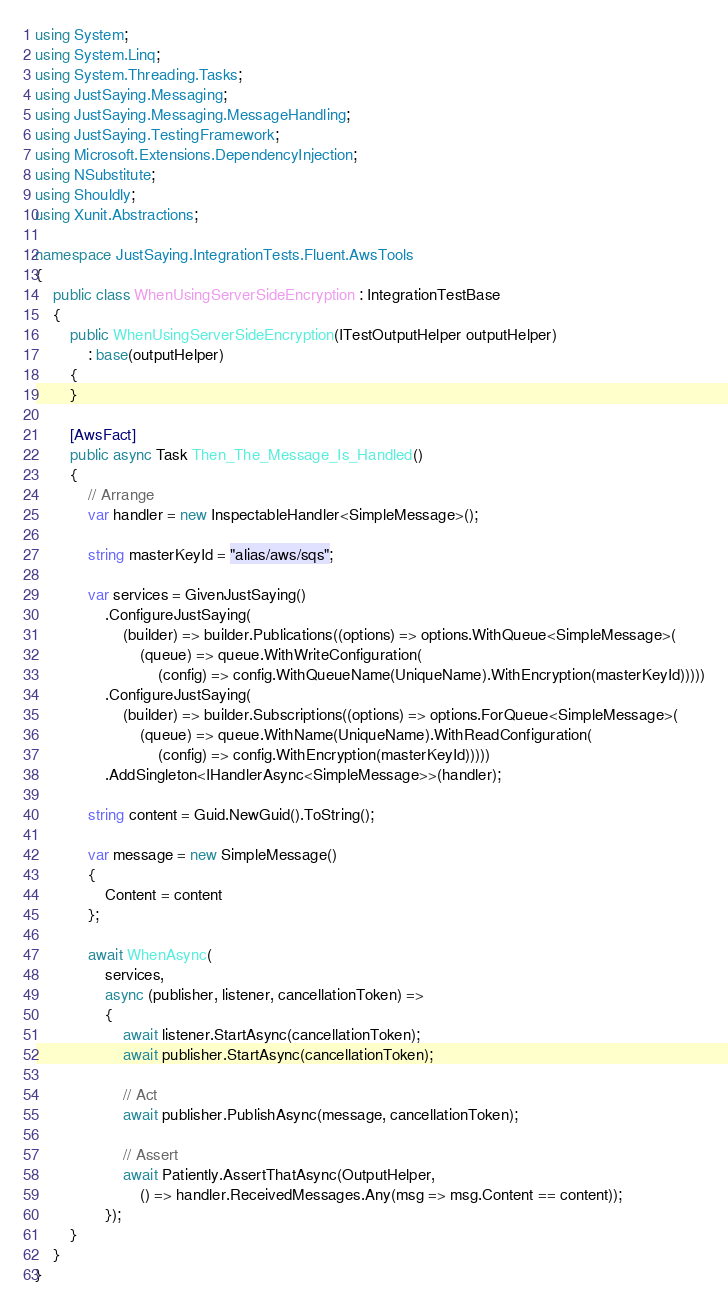<code> <loc_0><loc_0><loc_500><loc_500><_C#_>using System;
using System.Linq;
using System.Threading.Tasks;
using JustSaying.Messaging;
using JustSaying.Messaging.MessageHandling;
using JustSaying.TestingFramework;
using Microsoft.Extensions.DependencyInjection;
using NSubstitute;
using Shouldly;
using Xunit.Abstractions;

namespace JustSaying.IntegrationTests.Fluent.AwsTools
{
    public class WhenUsingServerSideEncryption : IntegrationTestBase
    {
        public WhenUsingServerSideEncryption(ITestOutputHelper outputHelper)
            : base(outputHelper)
        {
        }

        [AwsFact]
        public async Task Then_The_Message_Is_Handled()
        {
            // Arrange
            var handler = new InspectableHandler<SimpleMessage>();

            string masterKeyId = "alias/aws/sqs";

            var services = GivenJustSaying()
                .ConfigureJustSaying(
                    (builder) => builder.Publications((options) => options.WithQueue<SimpleMessage>(
                        (queue) => queue.WithWriteConfiguration(
                            (config) => config.WithQueueName(UniqueName).WithEncryption(masterKeyId)))))
                .ConfigureJustSaying(
                    (builder) => builder.Subscriptions((options) => options.ForQueue<SimpleMessage>(
                        (queue) => queue.WithName(UniqueName).WithReadConfiguration(
                            (config) => config.WithEncryption(masterKeyId)))))
                .AddSingleton<IHandlerAsync<SimpleMessage>>(handler);

            string content = Guid.NewGuid().ToString();

            var message = new SimpleMessage()
            {
                Content = content
            };

            await WhenAsync(
                services,
                async (publisher, listener, cancellationToken) =>
                {
                    await listener.StartAsync(cancellationToken);
                    await publisher.StartAsync(cancellationToken);

                    // Act
                    await publisher.PublishAsync(message, cancellationToken);

                    // Assert
                    await Patiently.AssertThatAsync(OutputHelper,
                        () => handler.ReceivedMessages.Any(msg => msg.Content == content));
                });
        }
    }
}
</code> 